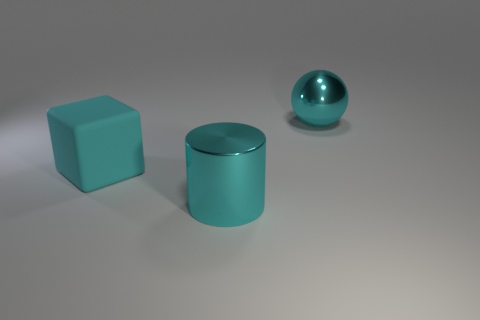Is there anything else that is made of the same material as the cyan block?
Give a very brief answer. No. The rubber thing that is the same size as the cyan metal cylinder is what color?
Your response must be concise. Cyan. What size is the cyan metallic object that is in front of the large cyan block on the left side of the large cyan metallic cylinder in front of the big cyan cube?
Your response must be concise. Large. There is a large thing right of the metal thing that is to the left of the cyan ball; what shape is it?
Provide a short and direct response. Sphere. There is a large metal thing to the left of the cyan metallic ball; is it the same color as the metal sphere?
Provide a short and direct response. Yes. There is a thing that is right of the matte block and in front of the large cyan metallic ball; what is its color?
Your answer should be compact. Cyan. Are there any cyan objects that have the same material as the cylinder?
Offer a terse response. Yes. What is the size of the cyan matte object?
Offer a very short reply. Large. What size is the metal thing to the left of the big cyan metal thing behind the matte block?
Your response must be concise. Large. What number of large red objects are there?
Offer a terse response. 0. 